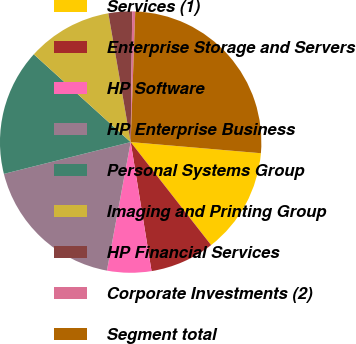Convert chart. <chart><loc_0><loc_0><loc_500><loc_500><pie_chart><fcel>Services (1)<fcel>Enterprise Storage and Servers<fcel>HP Software<fcel>HP Enterprise Business<fcel>Personal Systems Group<fcel>Imaging and Printing Group<fcel>HP Financial Services<fcel>Corporate Investments (2)<fcel>Segment total<nl><fcel>13.09%<fcel>8.0%<fcel>5.46%<fcel>18.18%<fcel>15.63%<fcel>10.55%<fcel>2.92%<fcel>0.37%<fcel>25.8%<nl></chart> 